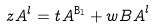<formula> <loc_0><loc_0><loc_500><loc_500>z _ { \tt } { A } ^ { l } & = t _ { \tt } { A } ^ { \tt { B } _ { l } } + w _ { \tt } { B A } ^ { l }</formula> 